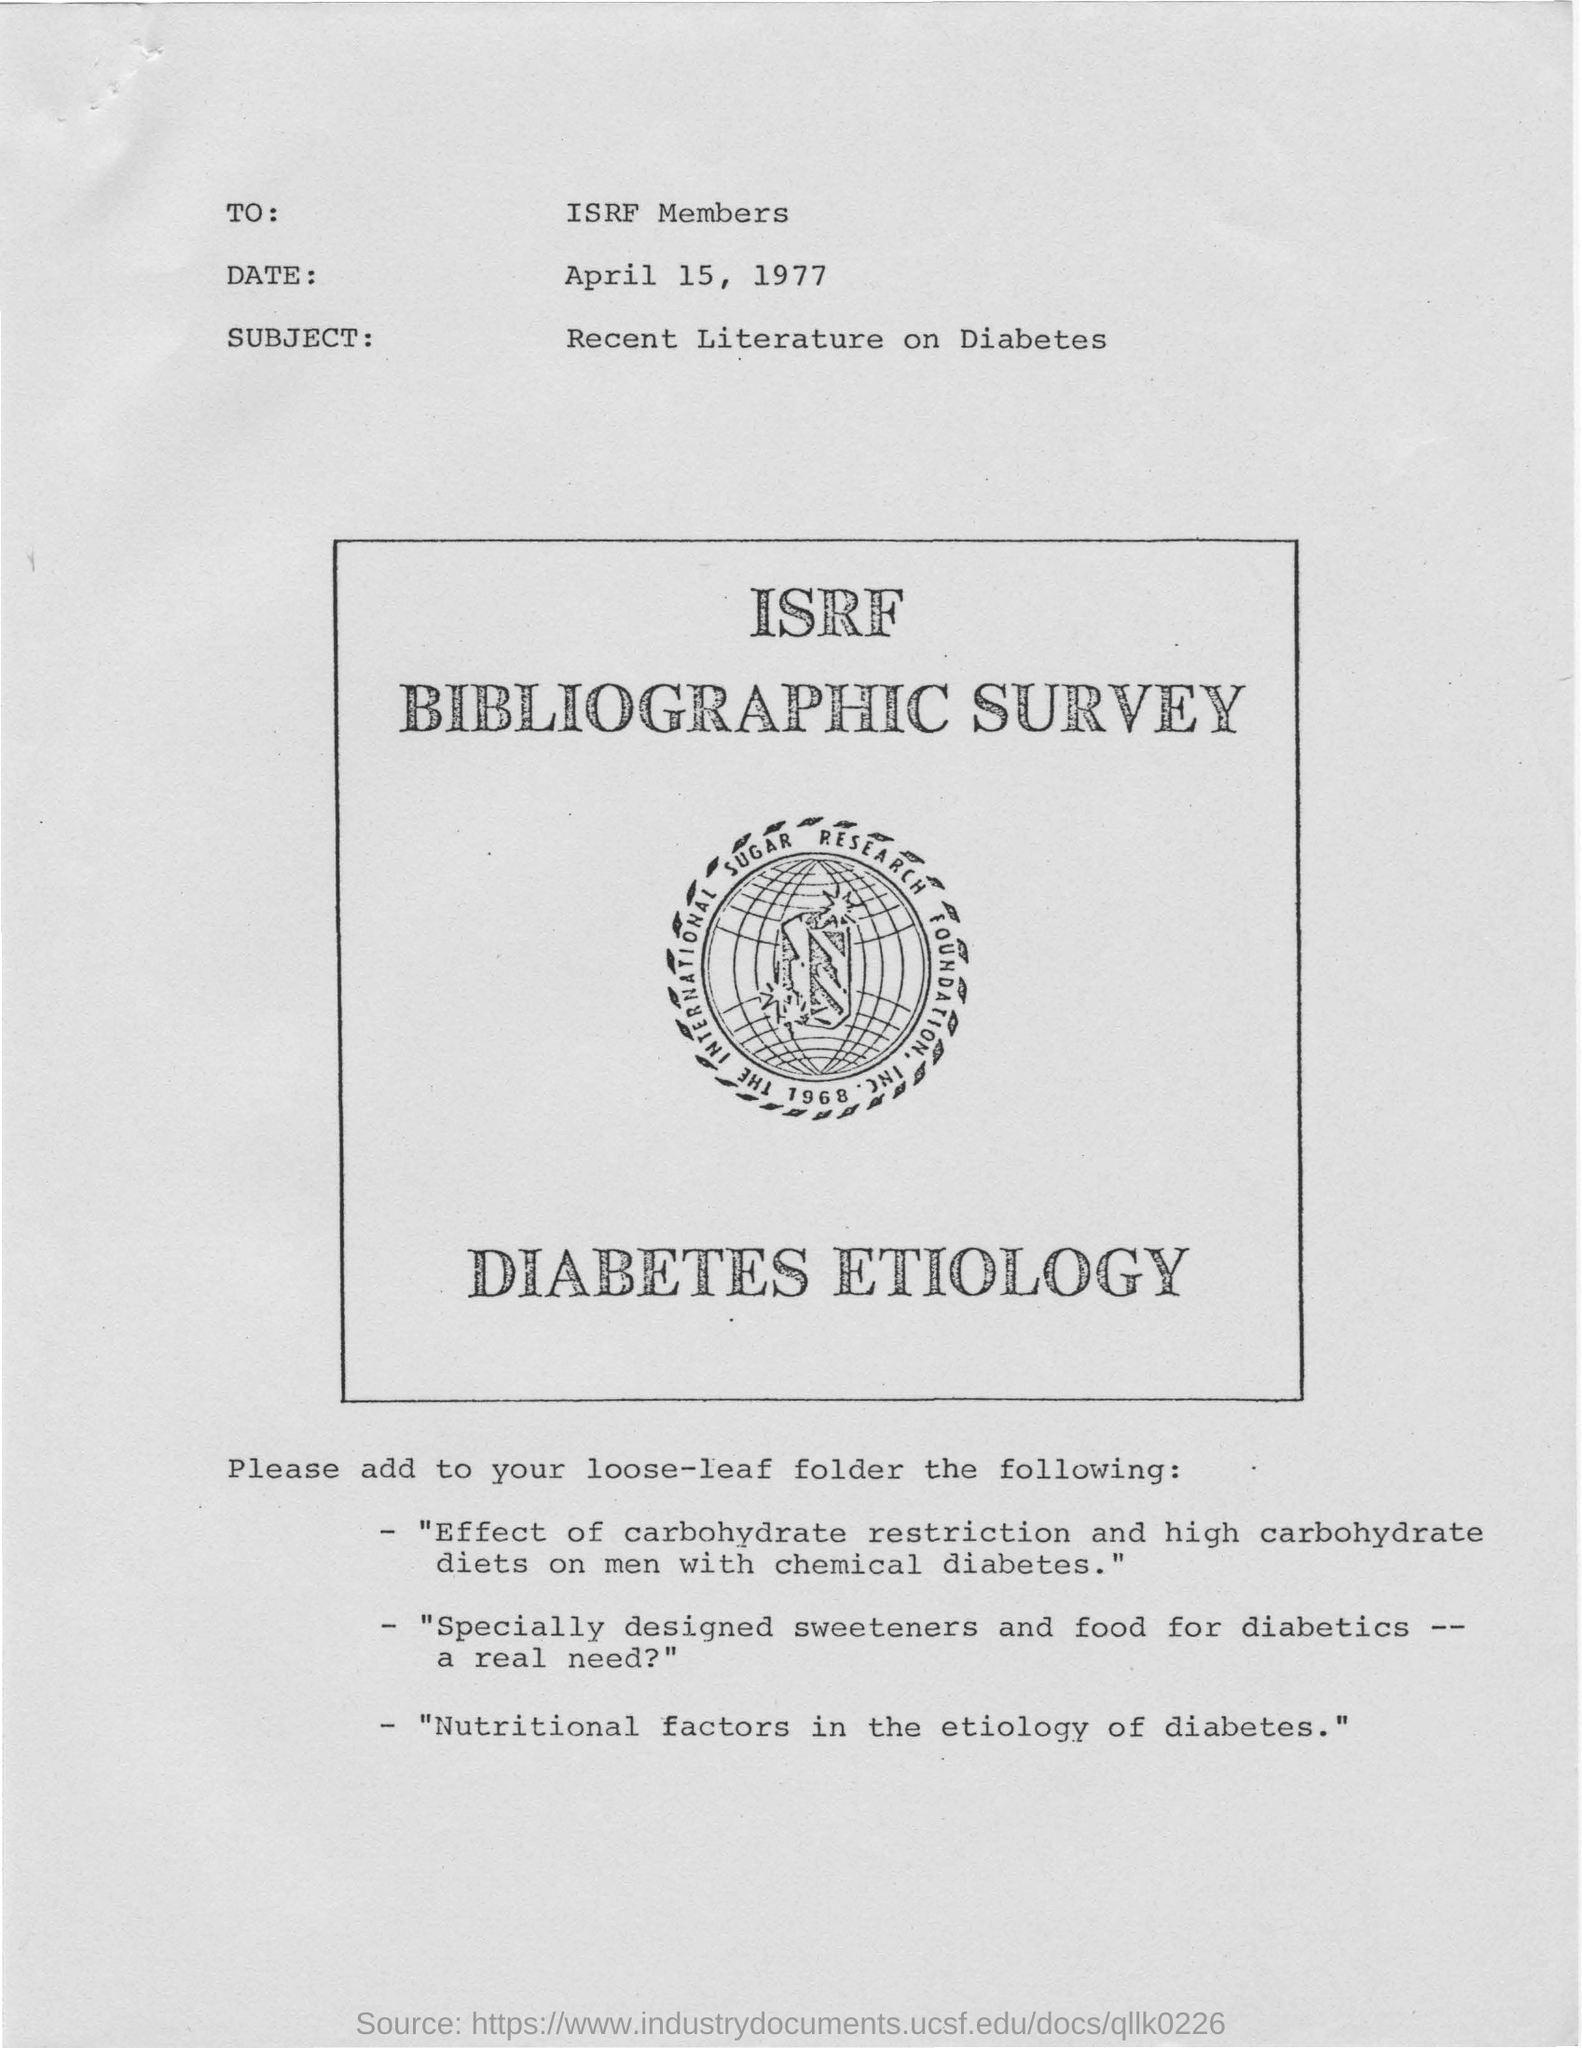What is the subject of the survey?
Keep it short and to the point. Recent Literature on Diabetes. Which is the date mentioned in the survey?
Offer a terse response. April 15, 1977. What is written right below the logo?
Offer a terse response. DIABETES ETIOLOGY. 